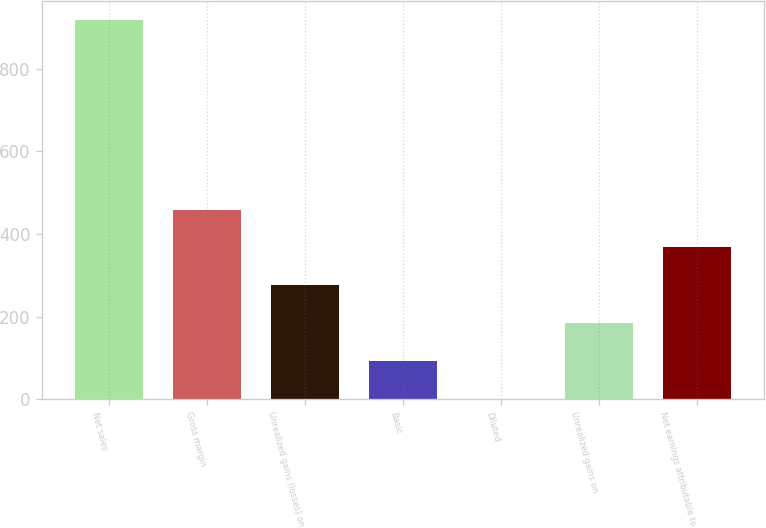Convert chart to OTSL. <chart><loc_0><loc_0><loc_500><loc_500><bar_chart><fcel>Net sales<fcel>Gross margin<fcel>Unrealized gains (losses) on<fcel>Basic<fcel>Diluted<fcel>Unrealized gains on<fcel>Net earnings attributable to<nl><fcel>917.1<fcel>458.87<fcel>275.59<fcel>92.31<fcel>0.67<fcel>183.95<fcel>367.23<nl></chart> 